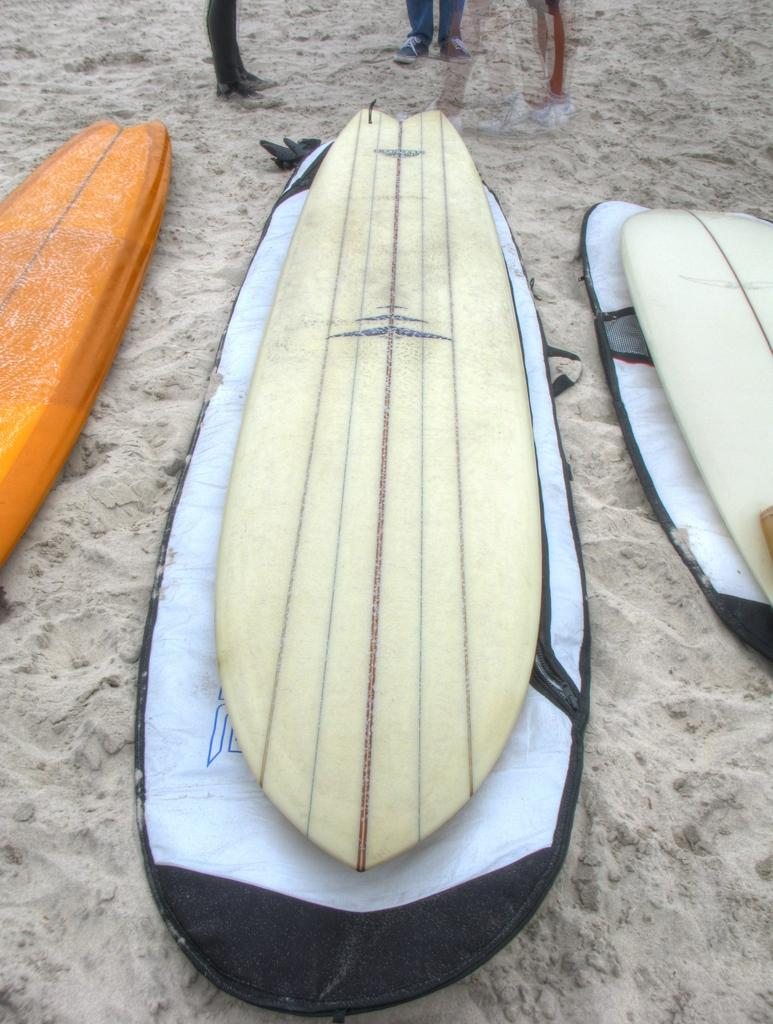What objects are in the center of the image? There are three surfboards in the center of the image. What type of surface is visible at the bottom of the image? There is sand visible at the bottom of the image. What type of statement can be seen written on the sand in the image? There is no statement written on the sand in the image. How many secretaries are present in the image? There are no secretaries present in the image. What type of rodent can be seen playing on the surfboards in the image? There are no rodents, such as mice, present in the image. 